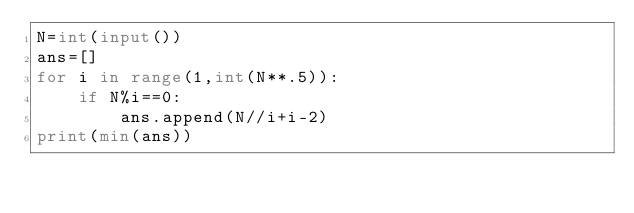<code> <loc_0><loc_0><loc_500><loc_500><_Python_>N=int(input())
ans=[]
for i in range(1,int(N**.5)):
    if N%i==0:
        ans.append(N//i+i-2)
print(min(ans))</code> 